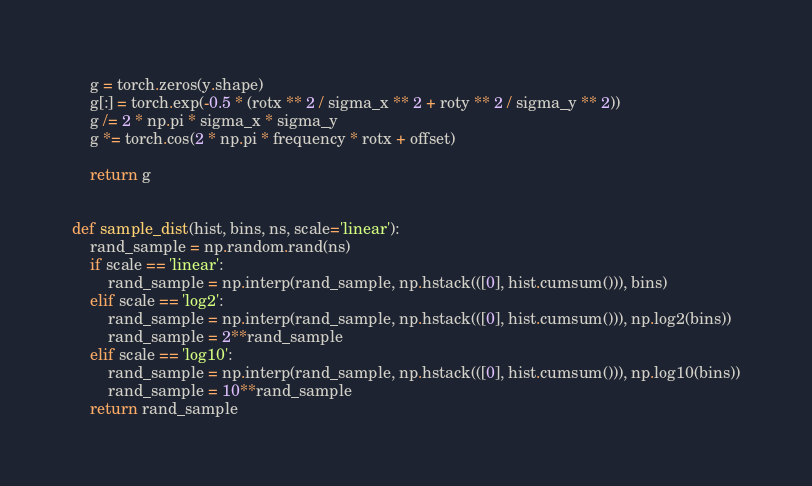<code> <loc_0><loc_0><loc_500><loc_500><_Python_>    g = torch.zeros(y.shape)
    g[:] = torch.exp(-0.5 * (rotx ** 2 / sigma_x ** 2 + roty ** 2 / sigma_y ** 2))
    g /= 2 * np.pi * sigma_x * sigma_y
    g *= torch.cos(2 * np.pi * frequency * rotx + offset)

    return g


def sample_dist(hist, bins, ns, scale='linear'):
    rand_sample = np.random.rand(ns)
    if scale == 'linear':
        rand_sample = np.interp(rand_sample, np.hstack(([0], hist.cumsum())), bins)
    elif scale == 'log2':
        rand_sample = np.interp(rand_sample, np.hstack(([0], hist.cumsum())), np.log2(bins))
        rand_sample = 2**rand_sample
    elif scale == 'log10':
        rand_sample = np.interp(rand_sample, np.hstack(([0], hist.cumsum())), np.log10(bins))
        rand_sample = 10**rand_sample
    return rand_sample

</code> 